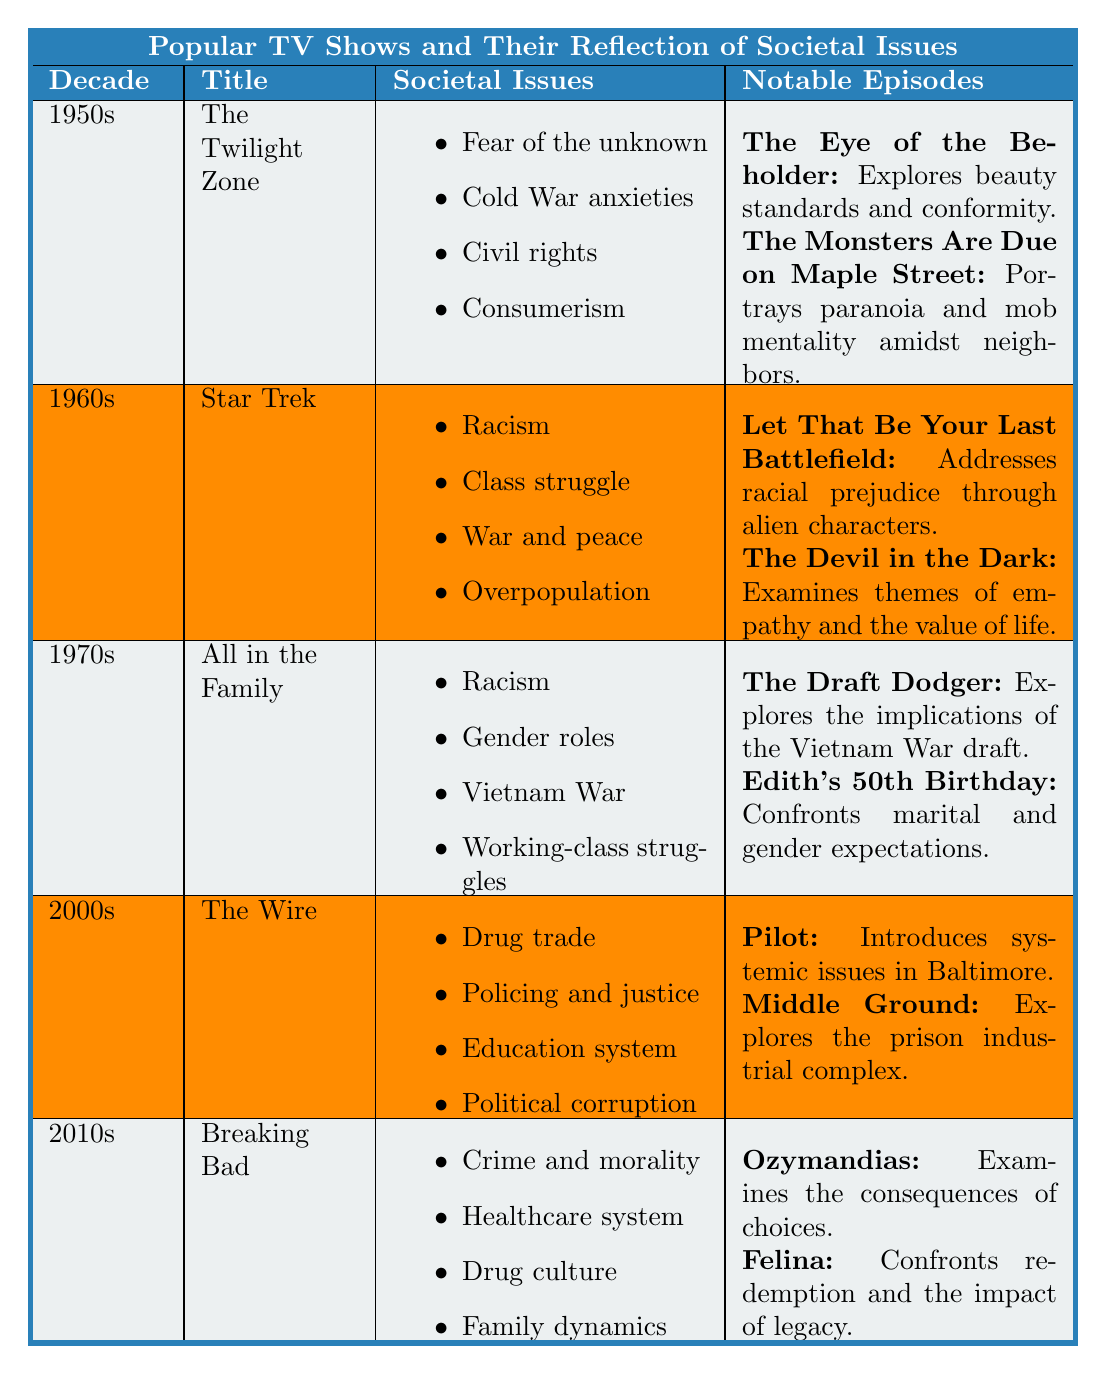What themes are explored in the 1970s show "All in the Family"? The themes listed for "All in the Family" in the table include racism, gender roles, Vietnam War, and working-class struggles.
Answer: Racism, gender roles, Vietnam War, working-class struggles Which show from the 1980s discusses family dynamics? Referring to the data, "The Cosby Show" from the 1980s includes family dynamics as one of its societal issues.
Answer: The Cosby Show True or False: "Breaking Bad" addresses class struggles as one of its societal issues. The table indicates that "Breaking Bad" focuses on crime and morality, the healthcare system, drug culture, and family dynamics, but does not mention class struggles.
Answer: False What notable episode from "The Twilight Zone" examines mob mentality? The episode "The Monsters Are Due on Maple Street" from "The Twilight Zone" is noted for portraying paranoia and mob mentality.
Answer: The Monsters Are Due on Maple Street Which decade's shows reflect issues related to the drug trade? "The Wire" from the 2000s clearly reflects issues related to the drug trade, as noted in the table.
Answer: 2000s List the societal issues addressed in "The Fresh Prince of Bel-Air". According to the table, "The Fresh Prince of Bel-Air" addresses class disparity, family and community, and identity and race.
Answer: Class disparity, family and community, identity and race How do the themes of "Star Trek" from the 1960s compare to those of "Breaking Bad" from the 2010s in terms of societal issues? "Star Trek" addresses racism, class struggle, war and peace, and overpopulation, while "Breaking Bad" focuses on crime and morality, healthcare system, drug culture, and family dynamics. Although both shows address social issues, their focus areas differ significantly.
Answer: Different societal issues What is the primary societal concern highlighted in the 2000s show "The Wire"? "The Wire" highlights multiple societal concerns, with a primary focus on the drug trade, policing and justice, education system, and political corruption.
Answer: Drug trade What episode addresses the implications of the Vietnam War draft in "All in the Family"? The episode titled "The Draft Dodger" explores implications of the Vietnam War draft as noted in the table.
Answer: The Draft Dodger How many societal issues are identified for the show "The Queen's Gambit" from the 2020s? "The Queen's Gambit" has four societal issues identified: gender equality, addiction, isolation, and classism, as per the table.
Answer: Four societal issues What consequence is examined in the notable episode "Ozymandias" from "Breaking Bad"? The episode "Ozymandias" examines the consequences of choices, according to the table.
Answer: Consequences of choices 